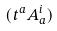<formula> <loc_0><loc_0><loc_500><loc_500>( t ^ { a } A _ { a } ^ { i } )</formula> 